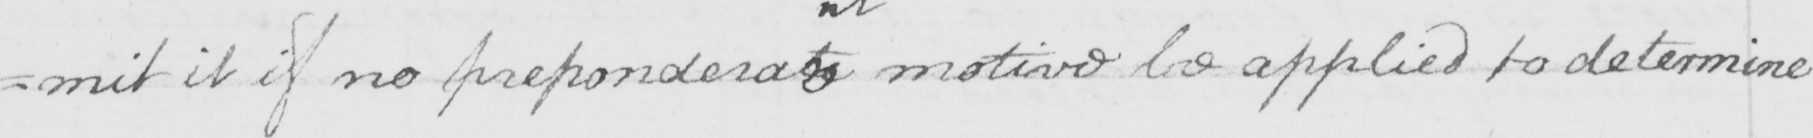What is written in this line of handwriting? =mit it if no preponderat motive be applied to determine 